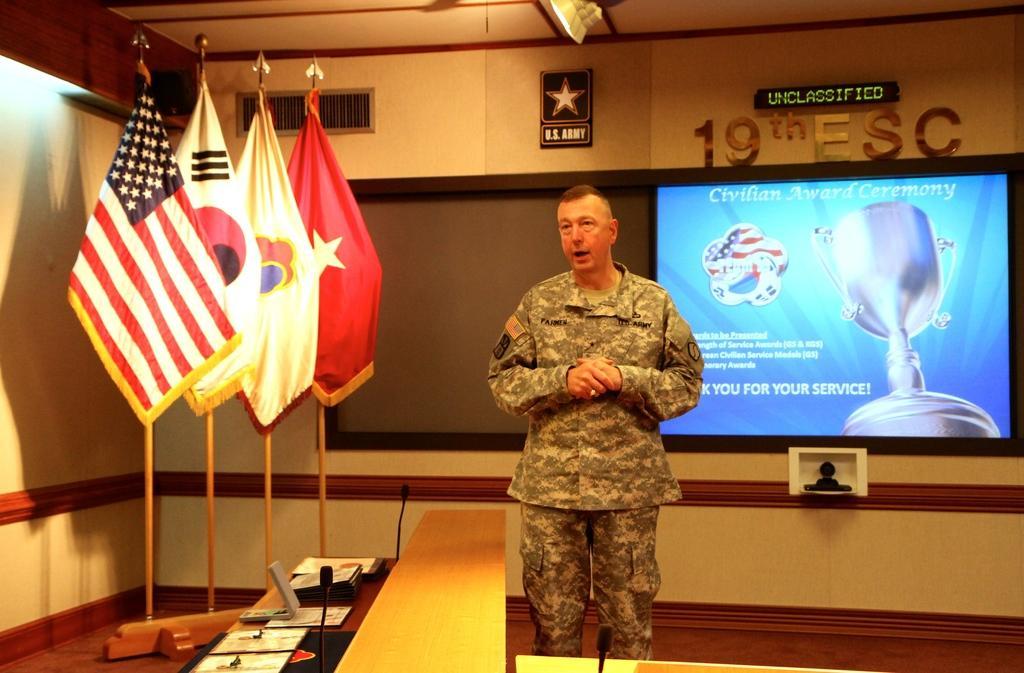Please provide a concise description of this image. In the middle there is a man and on the table we can see laptop,papers and microphones. In the background there are flags,wall,screen and light. 